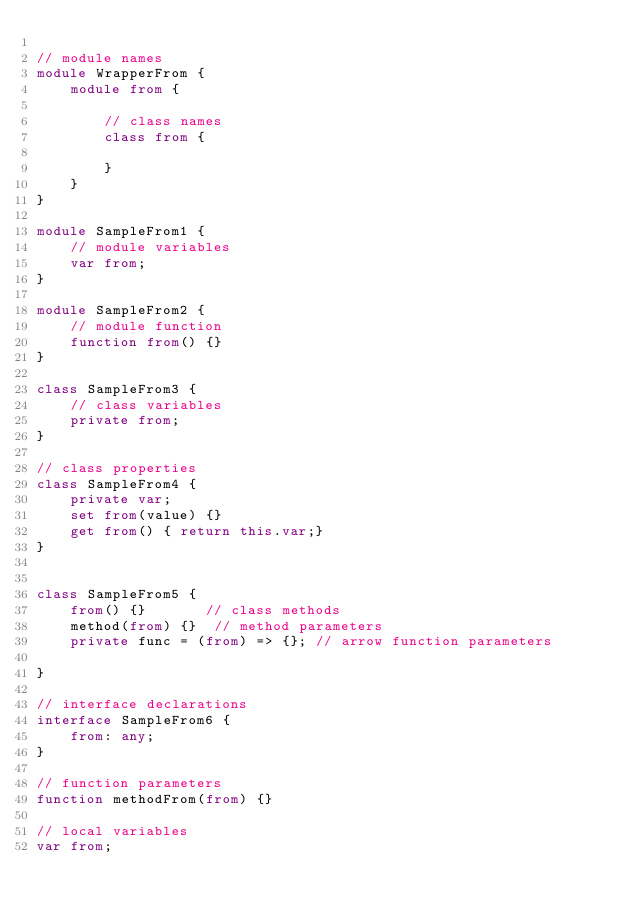Convert code to text. <code><loc_0><loc_0><loc_500><loc_500><_TypeScript_>
// module names
module WrapperFrom {
    module from {

        // class names
        class from {

        }
    }
}

module SampleFrom1 {
    // module variables
    var from;
}

module SampleFrom2 {
    // module function
    function from() {}
}

class SampleFrom3 {
    // class variables
    private from;
}

// class properties
class SampleFrom4 {
    private var;
    set from(value) {}
    get from() { return this.var;}
}


class SampleFrom5 {
    from() {}       // class methods
    method(from) {}  // method parameters
    private func = (from) => {}; // arrow function parameters

}

// interface declarations
interface SampleFrom6 {
    from: any;
}

// function parameters
function methodFrom(from) {}

// local variables
var from;
</code> 